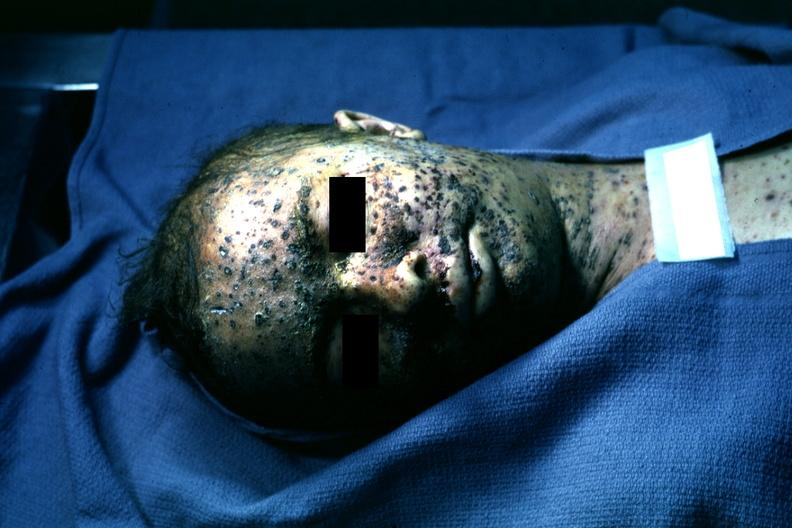does this image show extensive lesions?
Answer the question using a single word or phrase. Yes 